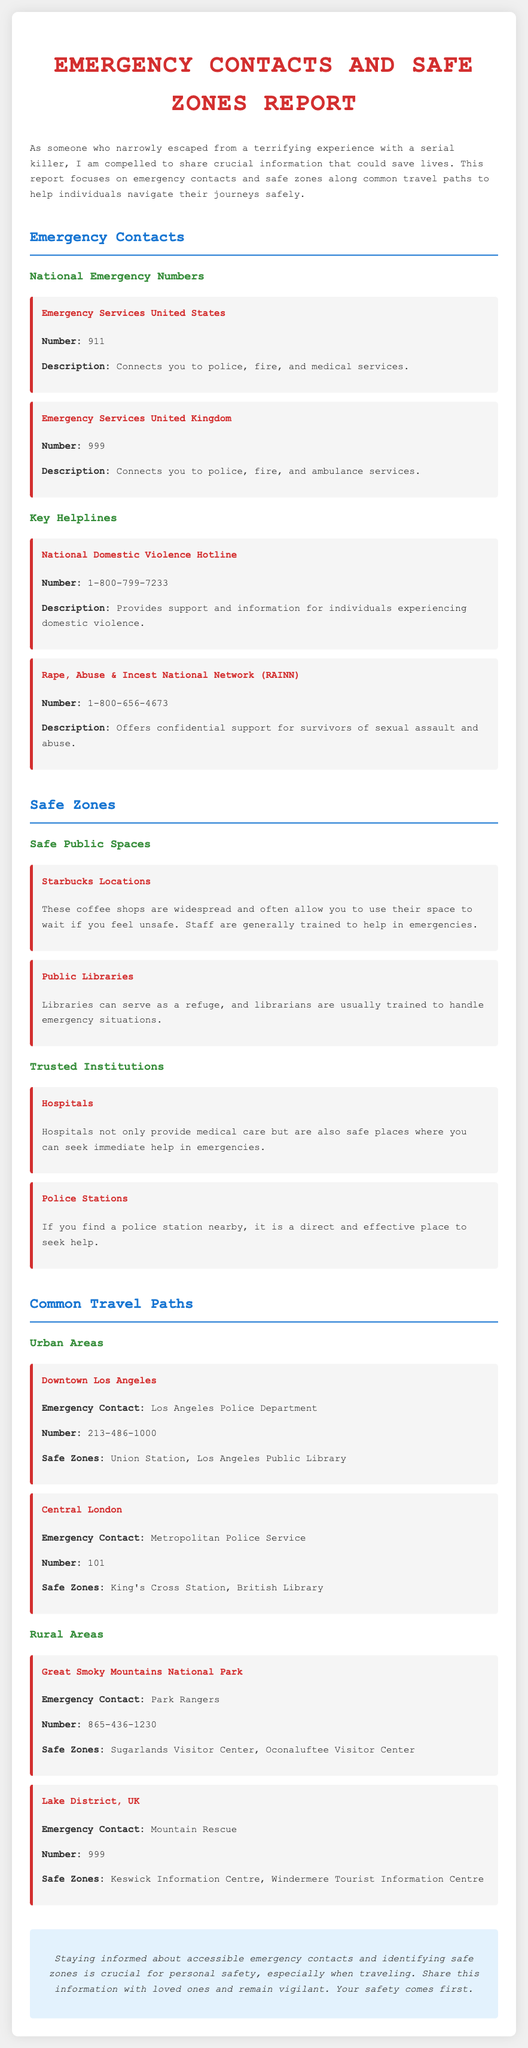what is the emergency number in the United States? The emergency number in the United States is listed under National Emergency Numbers in the document.
Answer: 911 what is the emergency contact number for the Metropolitan Police Service? The emergency contact number for the Metropolitan Police Service is provided in the Common Travel Paths section.
Answer: 101 name a safe zone in Downtown Los Angeles. The safe zones in Downtown Los Angeles are detailed under Common Travel Paths.
Answer: Union Station what does the National Domestic Violence Hotline provide? The description of the National Domestic Violence Hotline in the document explains its purpose.
Answer: Support and information for individuals experiencing domestic violence which coffee shop is mentioned as a safe public space? The document lists safe public spaces, including coffee shops as safe zones.
Answer: Starbucks Locations how many safe zones are listed for the Great Smoky Mountains National Park? The safe zones for the Great Smoky Mountains National Park are found under Safe Zones in the Common Travel Paths section.
Answer: 2 which facility is noted as a trusted institution for safety? The document categorizes trusted institutions and lists specific places.
Answer: Hospitals what kind of emergencies can you connect to by calling 999 in the UK? The description of 999 in the National Emergency Numbers section provides details about services connected through this number.
Answer: Police, fire, and ambulance services 